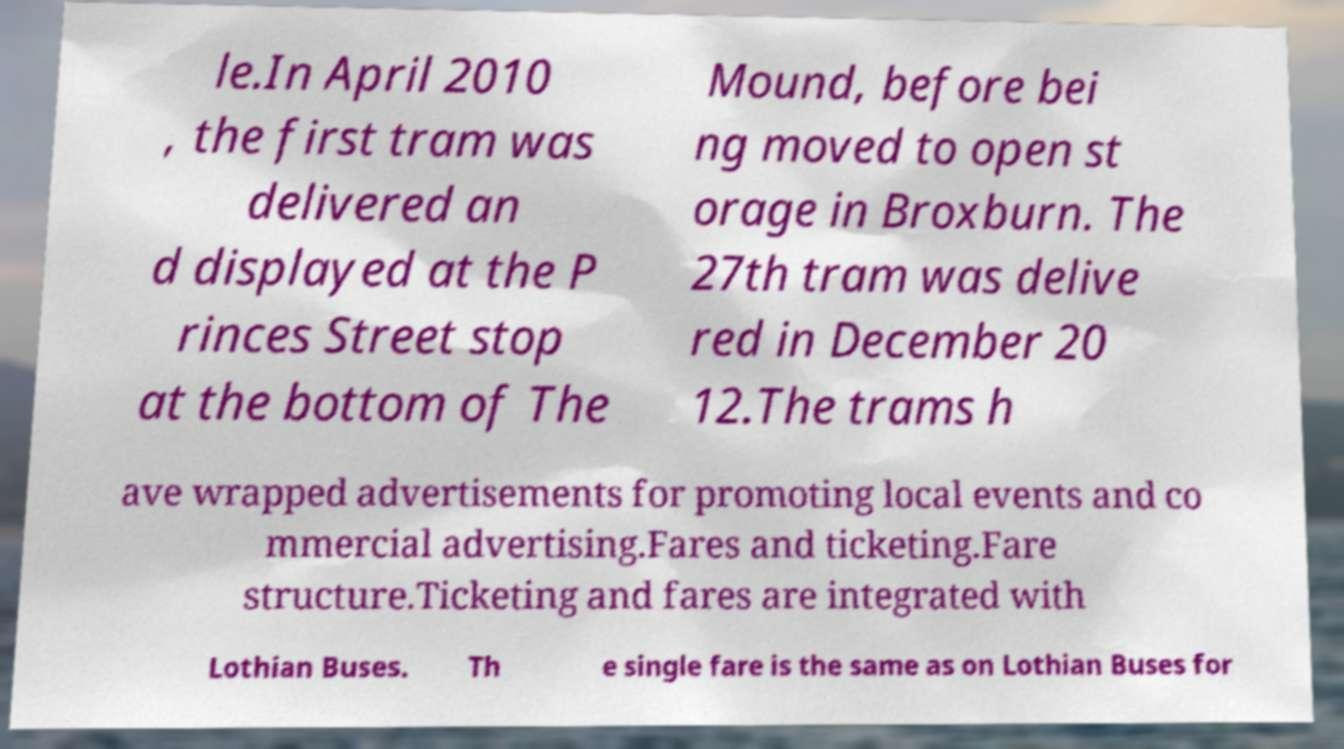There's text embedded in this image that I need extracted. Can you transcribe it verbatim? le.In April 2010 , the first tram was delivered an d displayed at the P rinces Street stop at the bottom of The Mound, before bei ng moved to open st orage in Broxburn. The 27th tram was delive red in December 20 12.The trams h ave wrapped advertisements for promoting local events and co mmercial advertising.Fares and ticketing.Fare structure.Ticketing and fares are integrated with Lothian Buses. Th e single fare is the same as on Lothian Buses for 